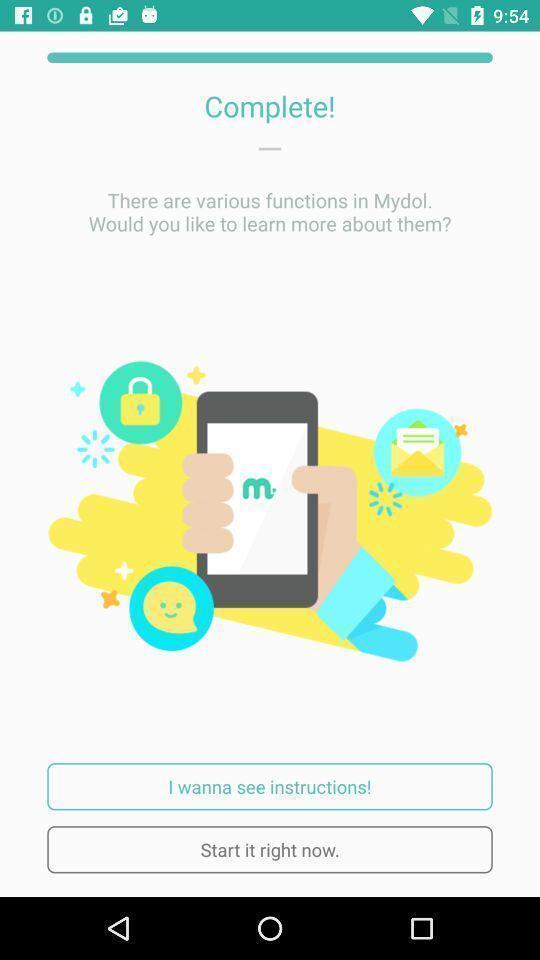Describe the visual elements of this screenshot. Screen showing complete with start it right now option. 